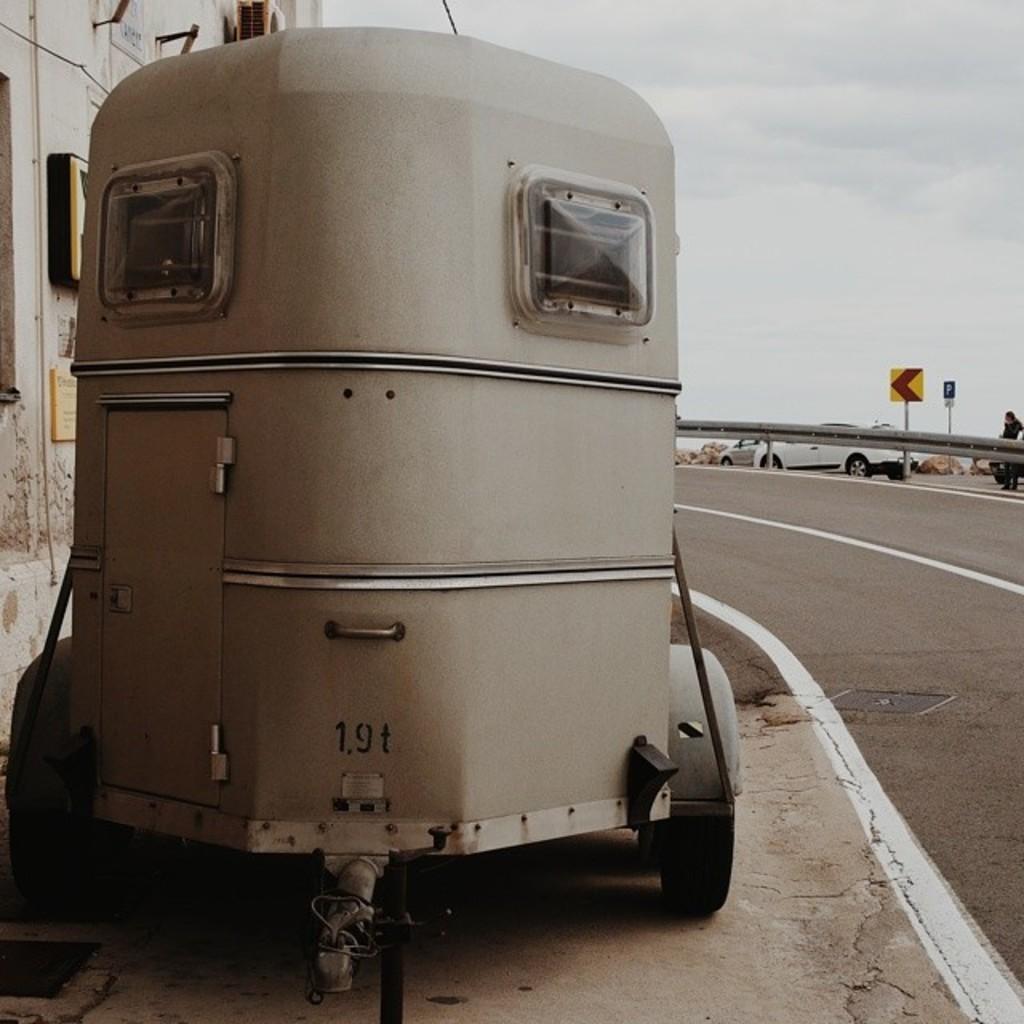Could you give a brief overview of what you see in this image? In the picture we can see a machine with wheels to it and beside it we can see a road and far away from it we can see a railing and behind it we can see a car which is white in color and a pole with a sign board and behind it we can see a sky with clouds. 